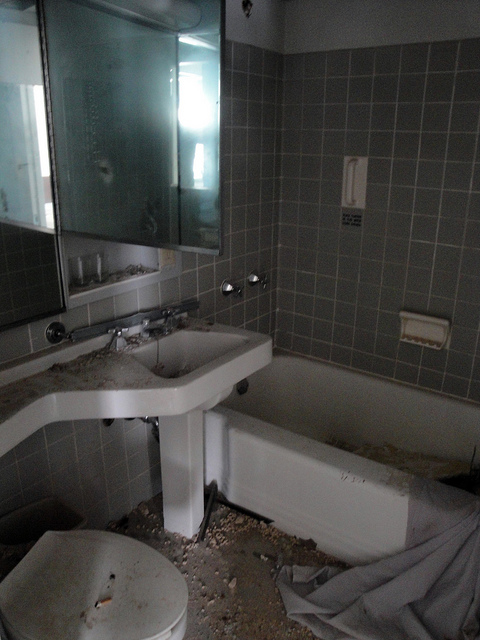<image>What kind of flooring is in the bathroom? I am not sure what kind of flooring is in the bathroom. It could be vinyl, tile, concrete, or none. What kind of flooring is in the bathroom? I am not sure what kind of flooring is in the bathroom. It can be seen vinyl, tile or concrete. 